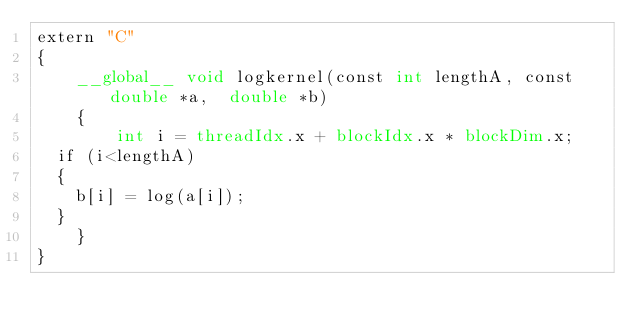<code> <loc_0><loc_0><loc_500><loc_500><_Cuda_>extern "C"  
{
    __global__ void logkernel(const int lengthA, const double *a,  double *b)
    {
        int i = threadIdx.x + blockIdx.x * blockDim.x;
	if (i<lengthA)
	{
	  b[i] = log(a[i]); 
	}
    }
}</code> 